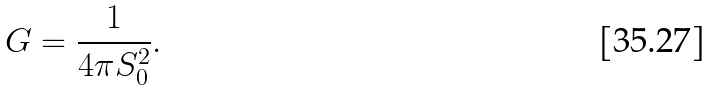Convert formula to latex. <formula><loc_0><loc_0><loc_500><loc_500>G = \frac { 1 } { 4 \pi S _ { 0 } ^ { 2 } } .</formula> 